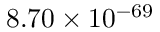Convert formula to latex. <formula><loc_0><loc_0><loc_500><loc_500>8 . 7 0 \times 1 0 ^ { - 6 9 }</formula> 